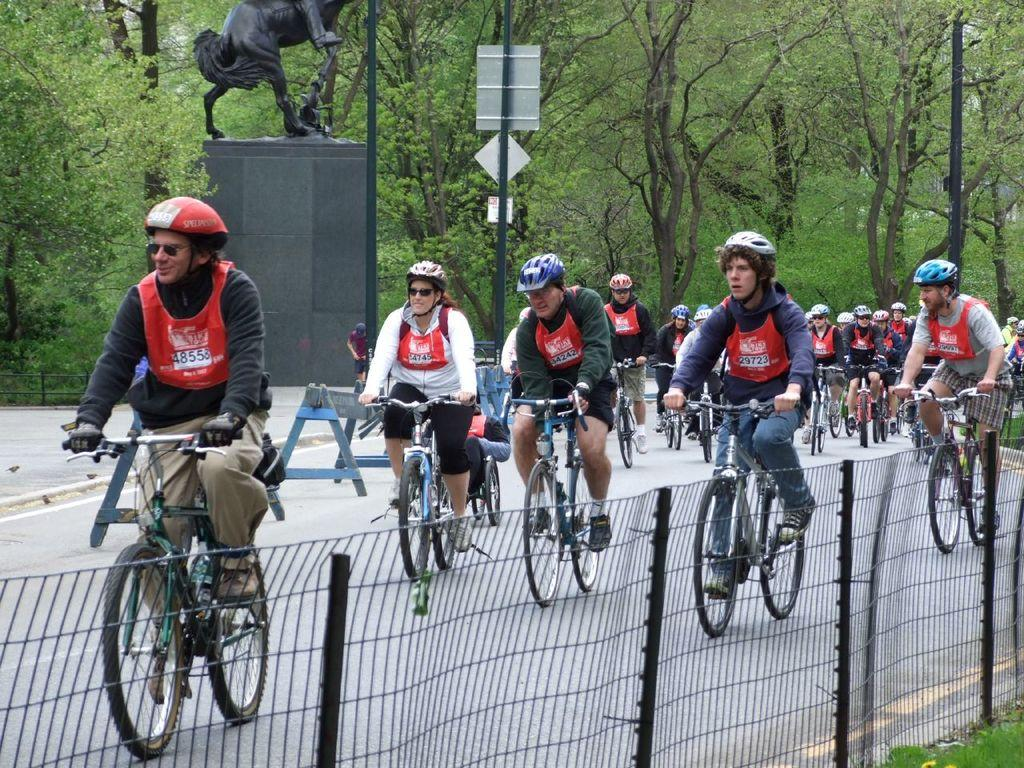What are the people in the image doing? The people in the image are cycling. Where are the people cycling? The people are on a path. What can be seen in the background of the image? There is a statue, two poles, and trees in the background of the image. Is there any barrier or enclosure visible in the image? Yes, there is a fence in the image. What type of mint is growing on the fence in the image? There is no mint visible in the image, as it features people cycling on a path with a fence and various background elements. 